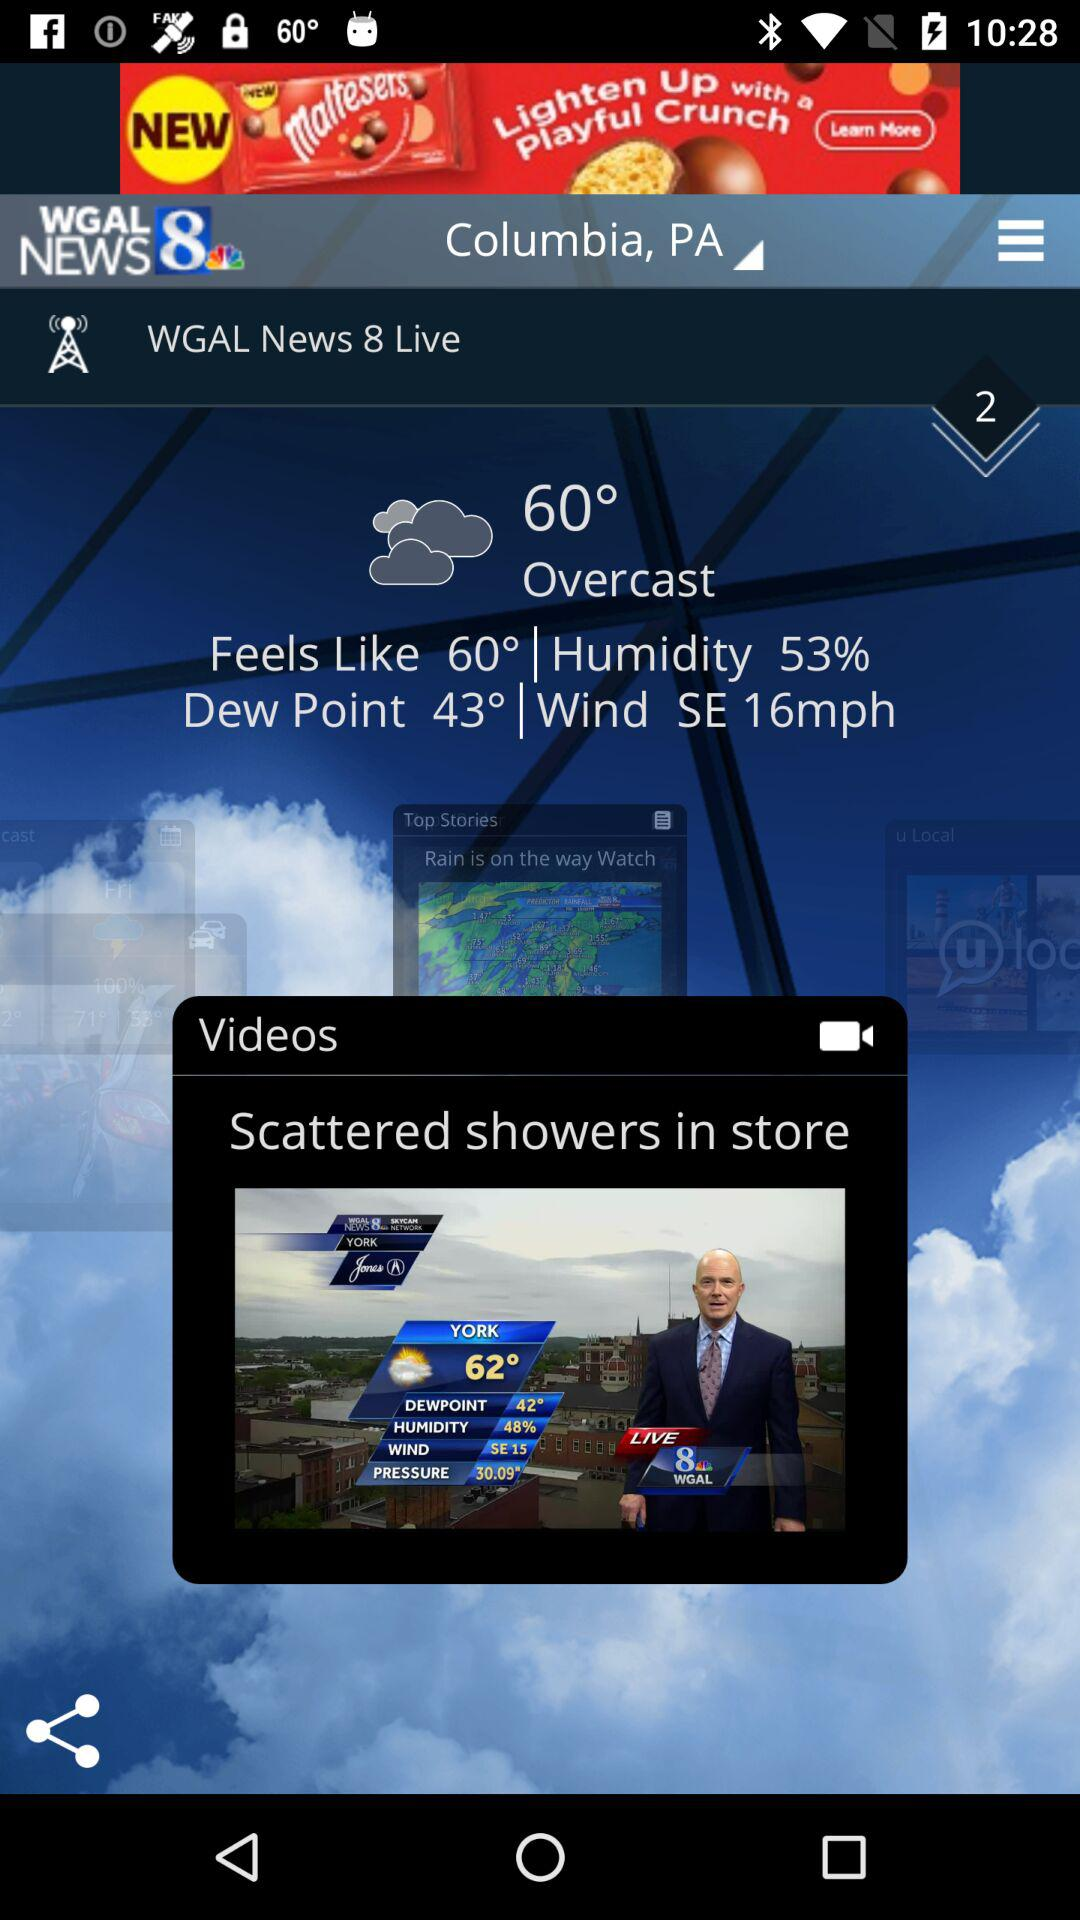How many more degrees Fahrenheit is the current temperature than the dew point?
Answer the question using a single word or phrase. 17 